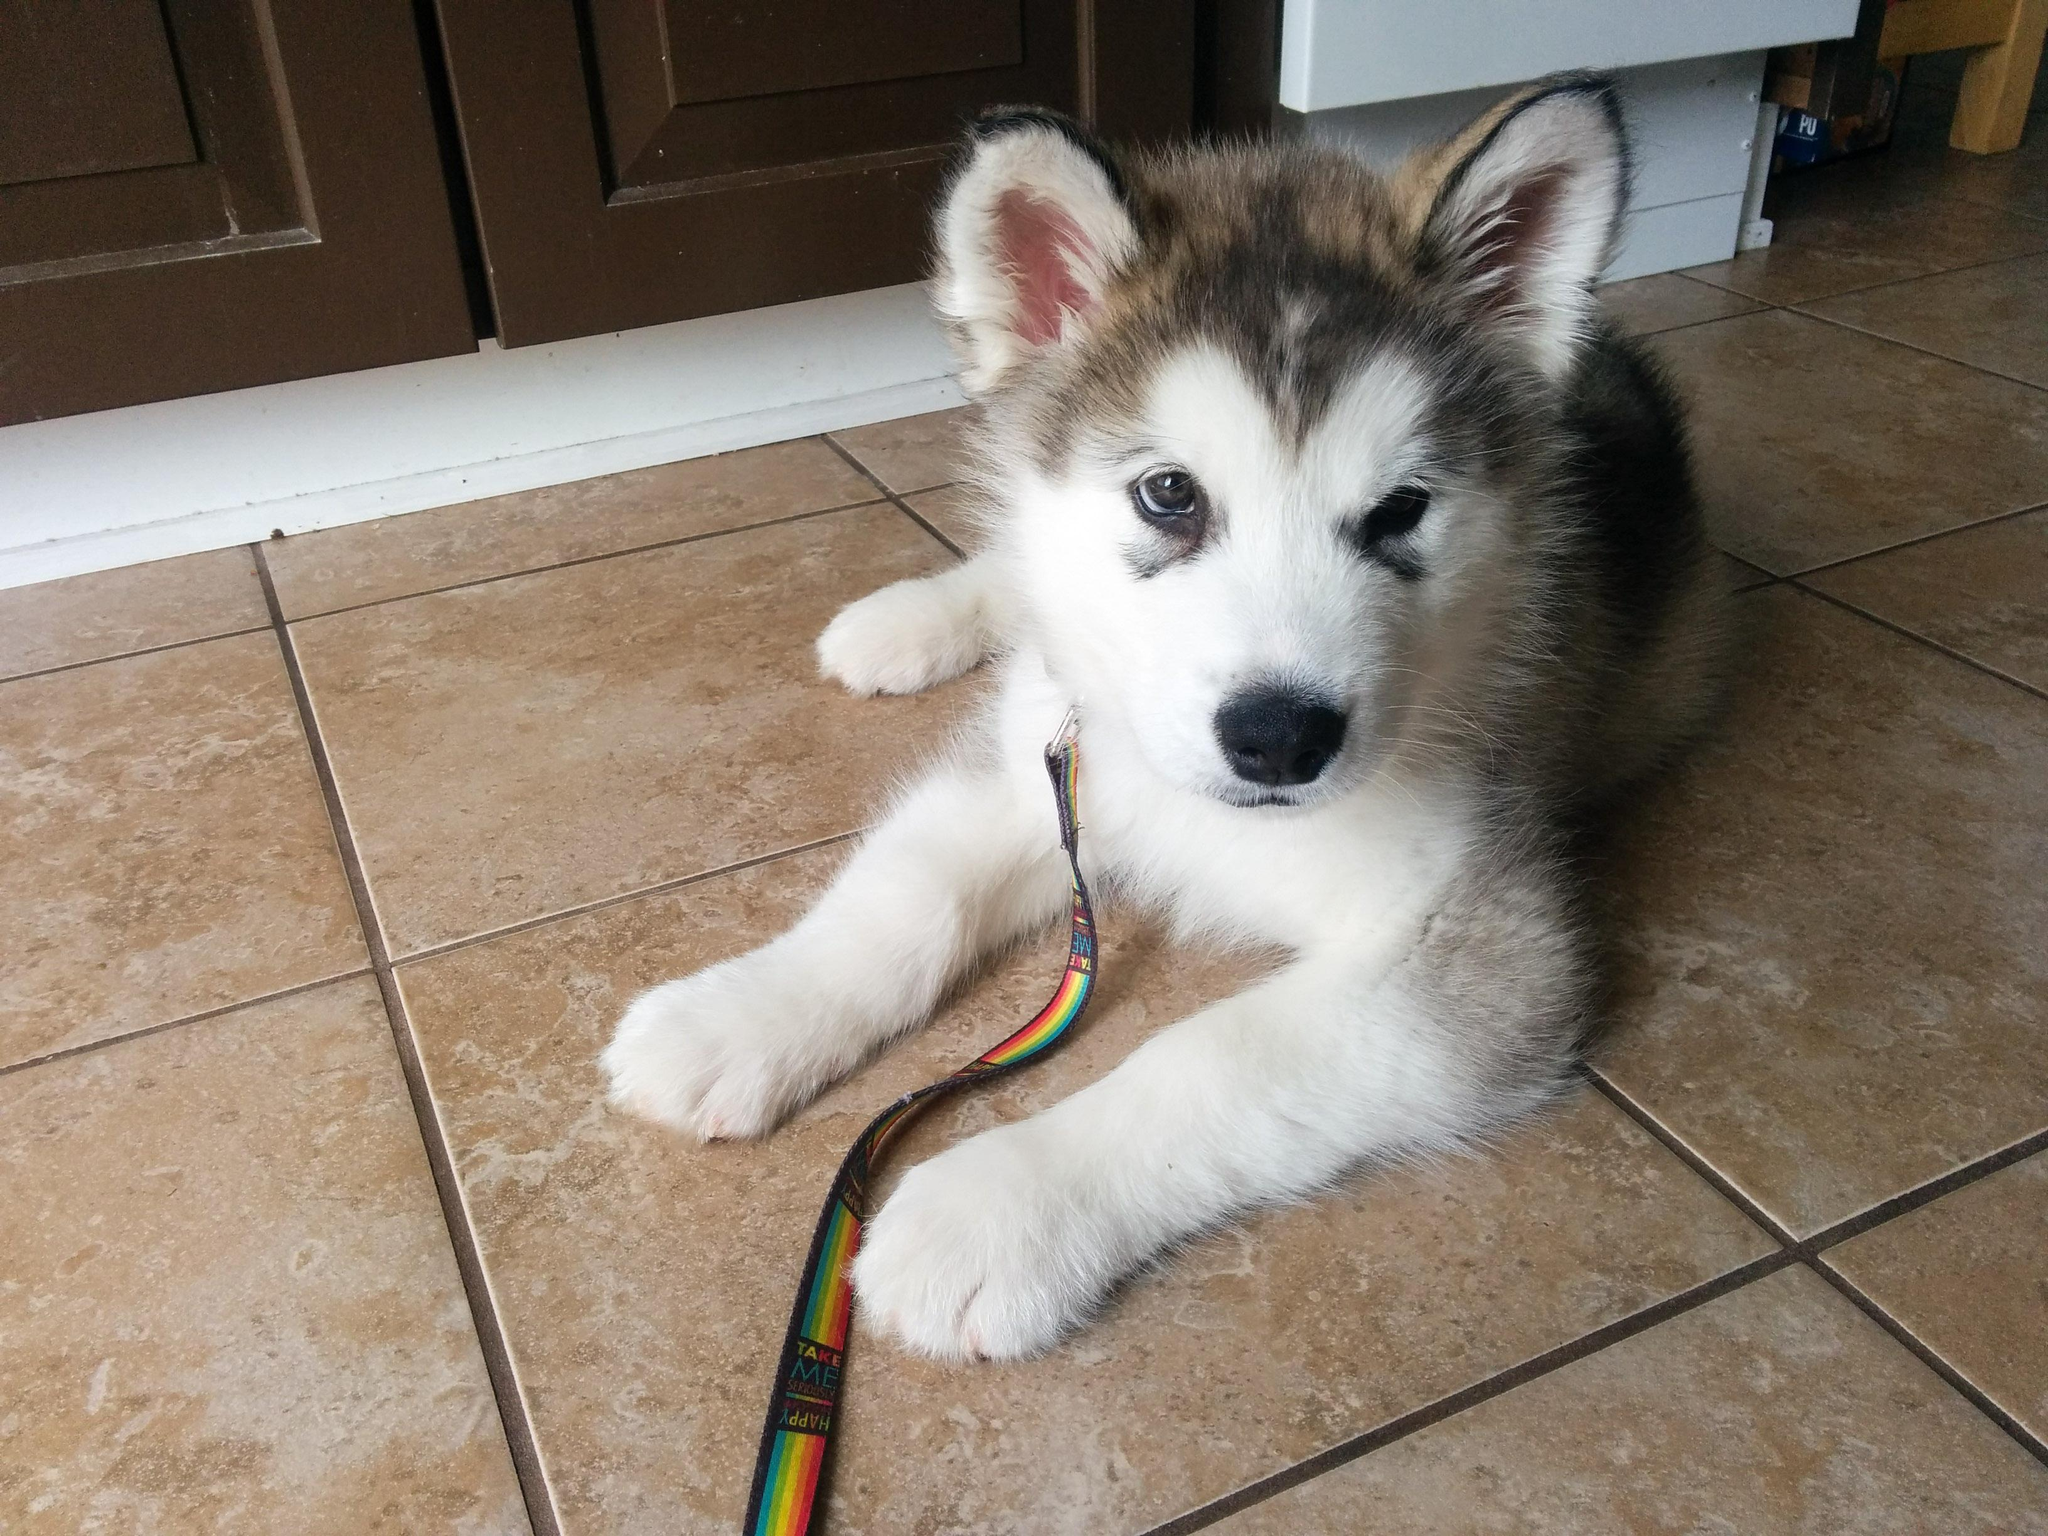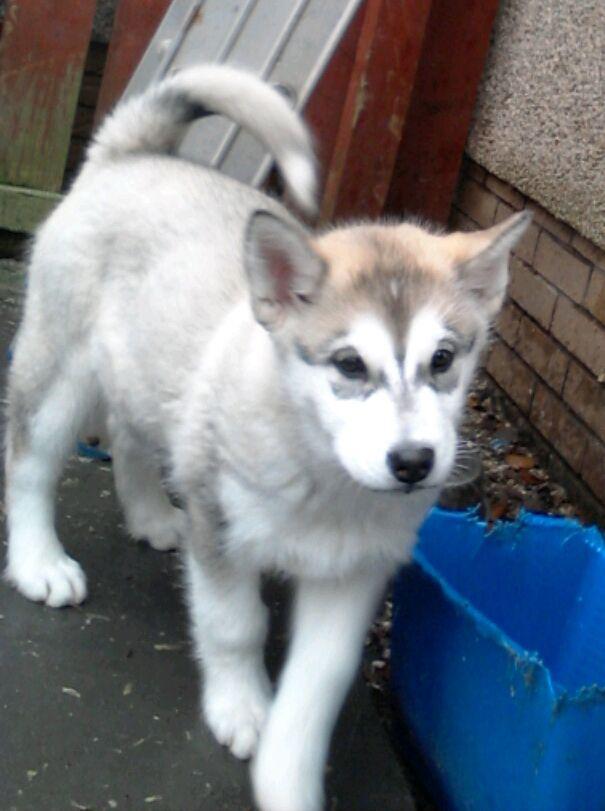The first image is the image on the left, the second image is the image on the right. Given the left and right images, does the statement "Neither of he images in the pair show an adult dog." hold true? Answer yes or no. Yes. The first image is the image on the left, the second image is the image on the right. For the images displayed, is the sentence "Each image contains one husky pup with upright ears and muted fur coloring, and one image shows a puppy reclining with front paws extended on a mottled beige floor." factually correct? Answer yes or no. Yes. 